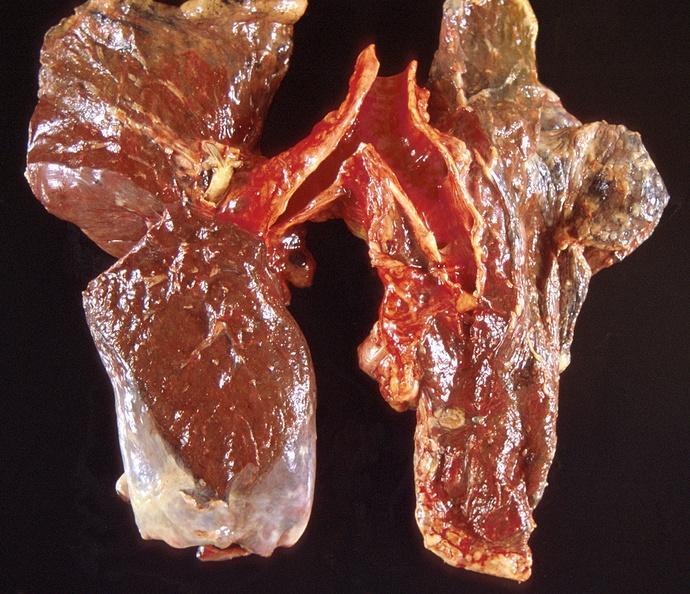does periprostatic vein thrombi show lung carcinoma?
Answer the question using a single word or phrase. No 